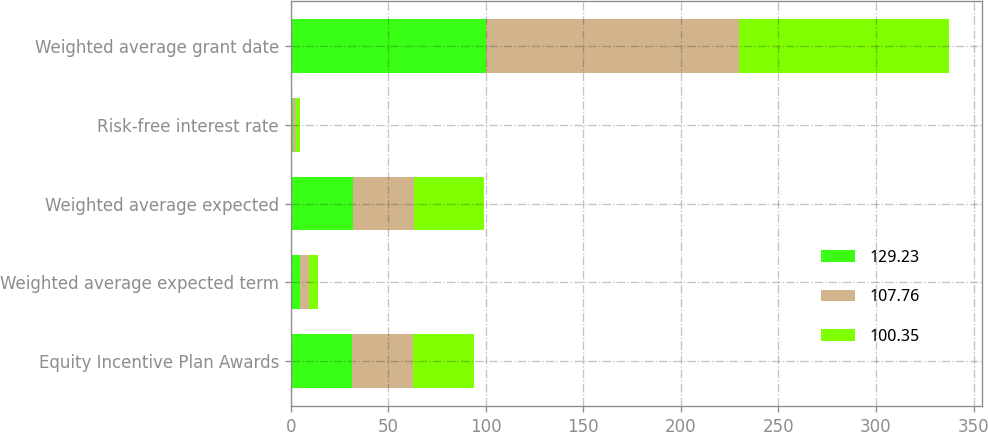Convert chart to OTSL. <chart><loc_0><loc_0><loc_500><loc_500><stacked_bar_chart><ecel><fcel>Equity Incentive Plan Awards<fcel>Weighted average expected term<fcel>Weighted average expected<fcel>Risk-free interest rate<fcel>Weighted average grant date<nl><fcel>129.23<fcel>31.3<fcel>4.8<fcel>31.7<fcel>1.32<fcel>100.35<nl><fcel>107.76<fcel>31.3<fcel>4.7<fcel>31.3<fcel>1.49<fcel>129.23<nl><fcel>100.35<fcel>31.3<fcel>4.6<fcel>35.9<fcel>1.72<fcel>107.76<nl></chart> 